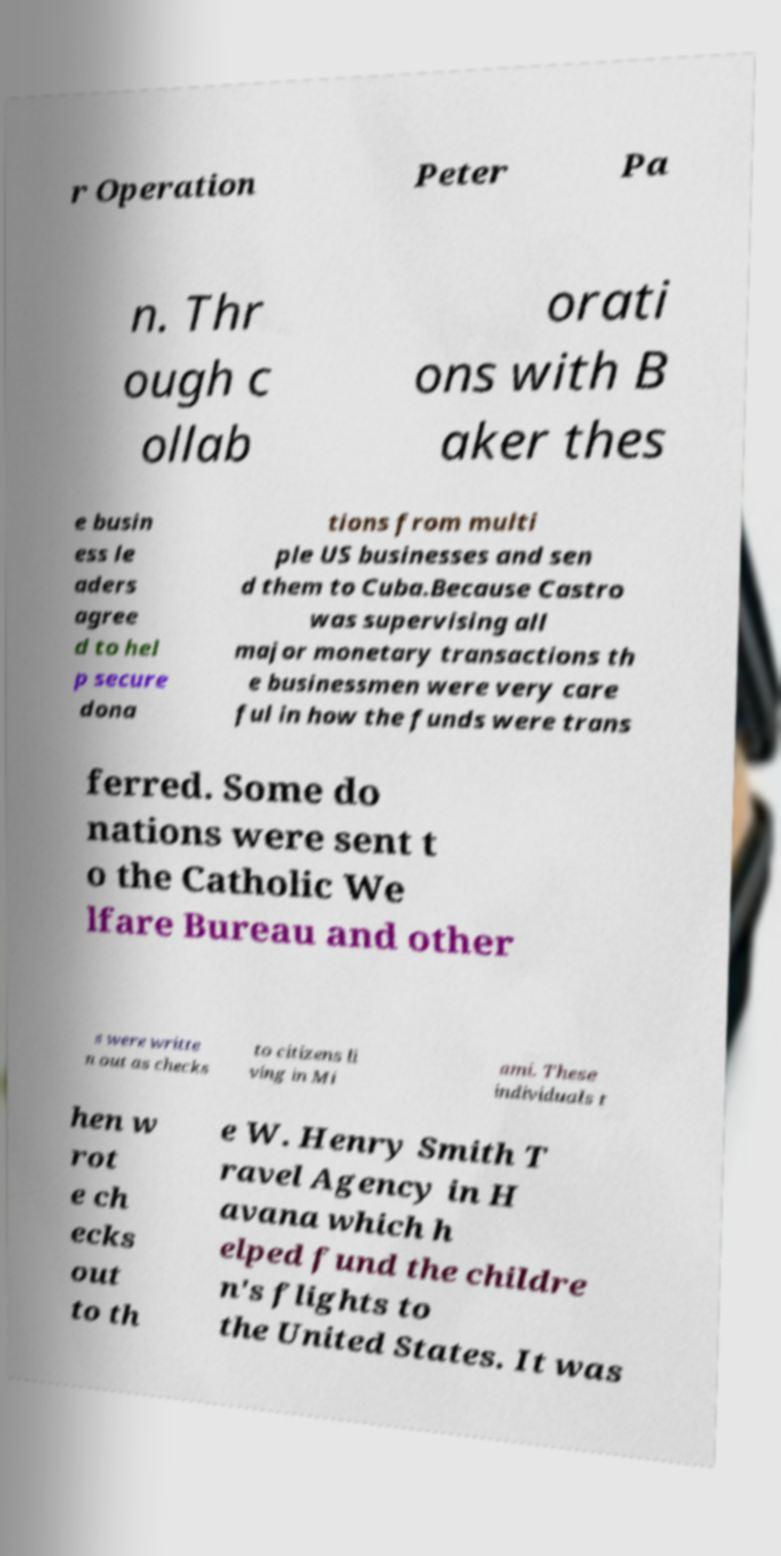What messages or text are displayed in this image? I need them in a readable, typed format. r Operation Peter Pa n. Thr ough c ollab orati ons with B aker thes e busin ess le aders agree d to hel p secure dona tions from multi ple US businesses and sen d them to Cuba.Because Castro was supervising all major monetary transactions th e businessmen were very care ful in how the funds were trans ferred. Some do nations were sent t o the Catholic We lfare Bureau and other s were writte n out as checks to citizens li ving in Mi ami. These individuals t hen w rot e ch ecks out to th e W. Henry Smith T ravel Agency in H avana which h elped fund the childre n's flights to the United States. It was 